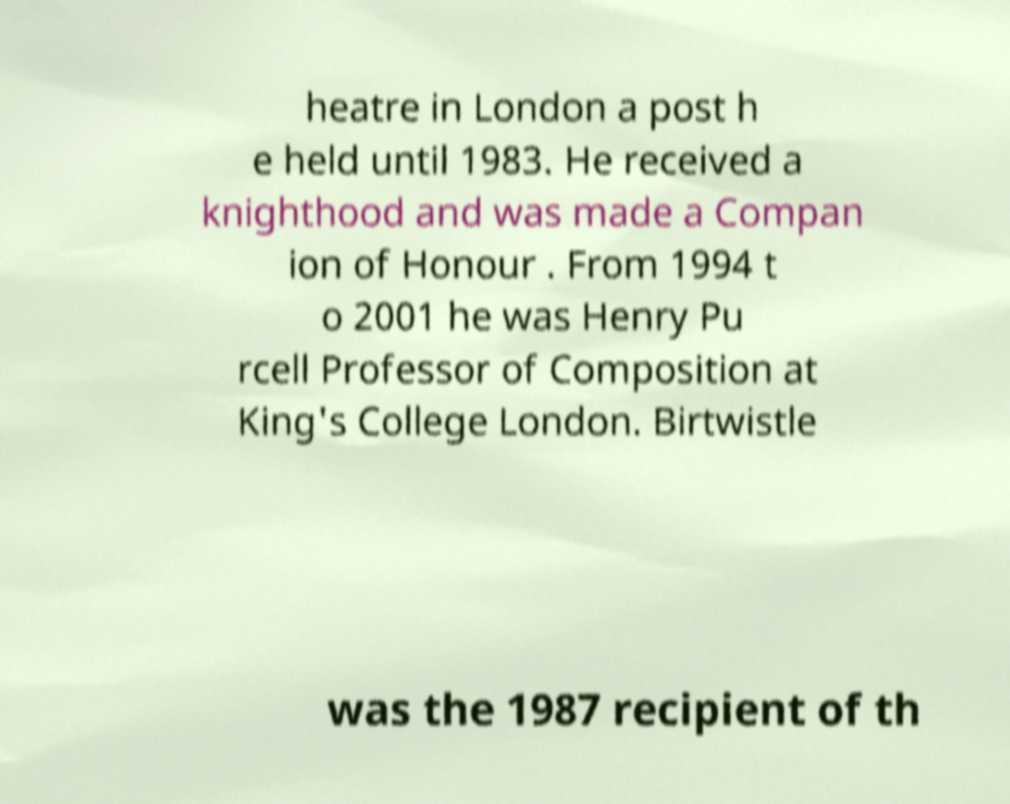Please read and relay the text visible in this image. What does it say? heatre in London a post h e held until 1983. He received a knighthood and was made a Compan ion of Honour . From 1994 t o 2001 he was Henry Pu rcell Professor of Composition at King's College London. Birtwistle was the 1987 recipient of th 